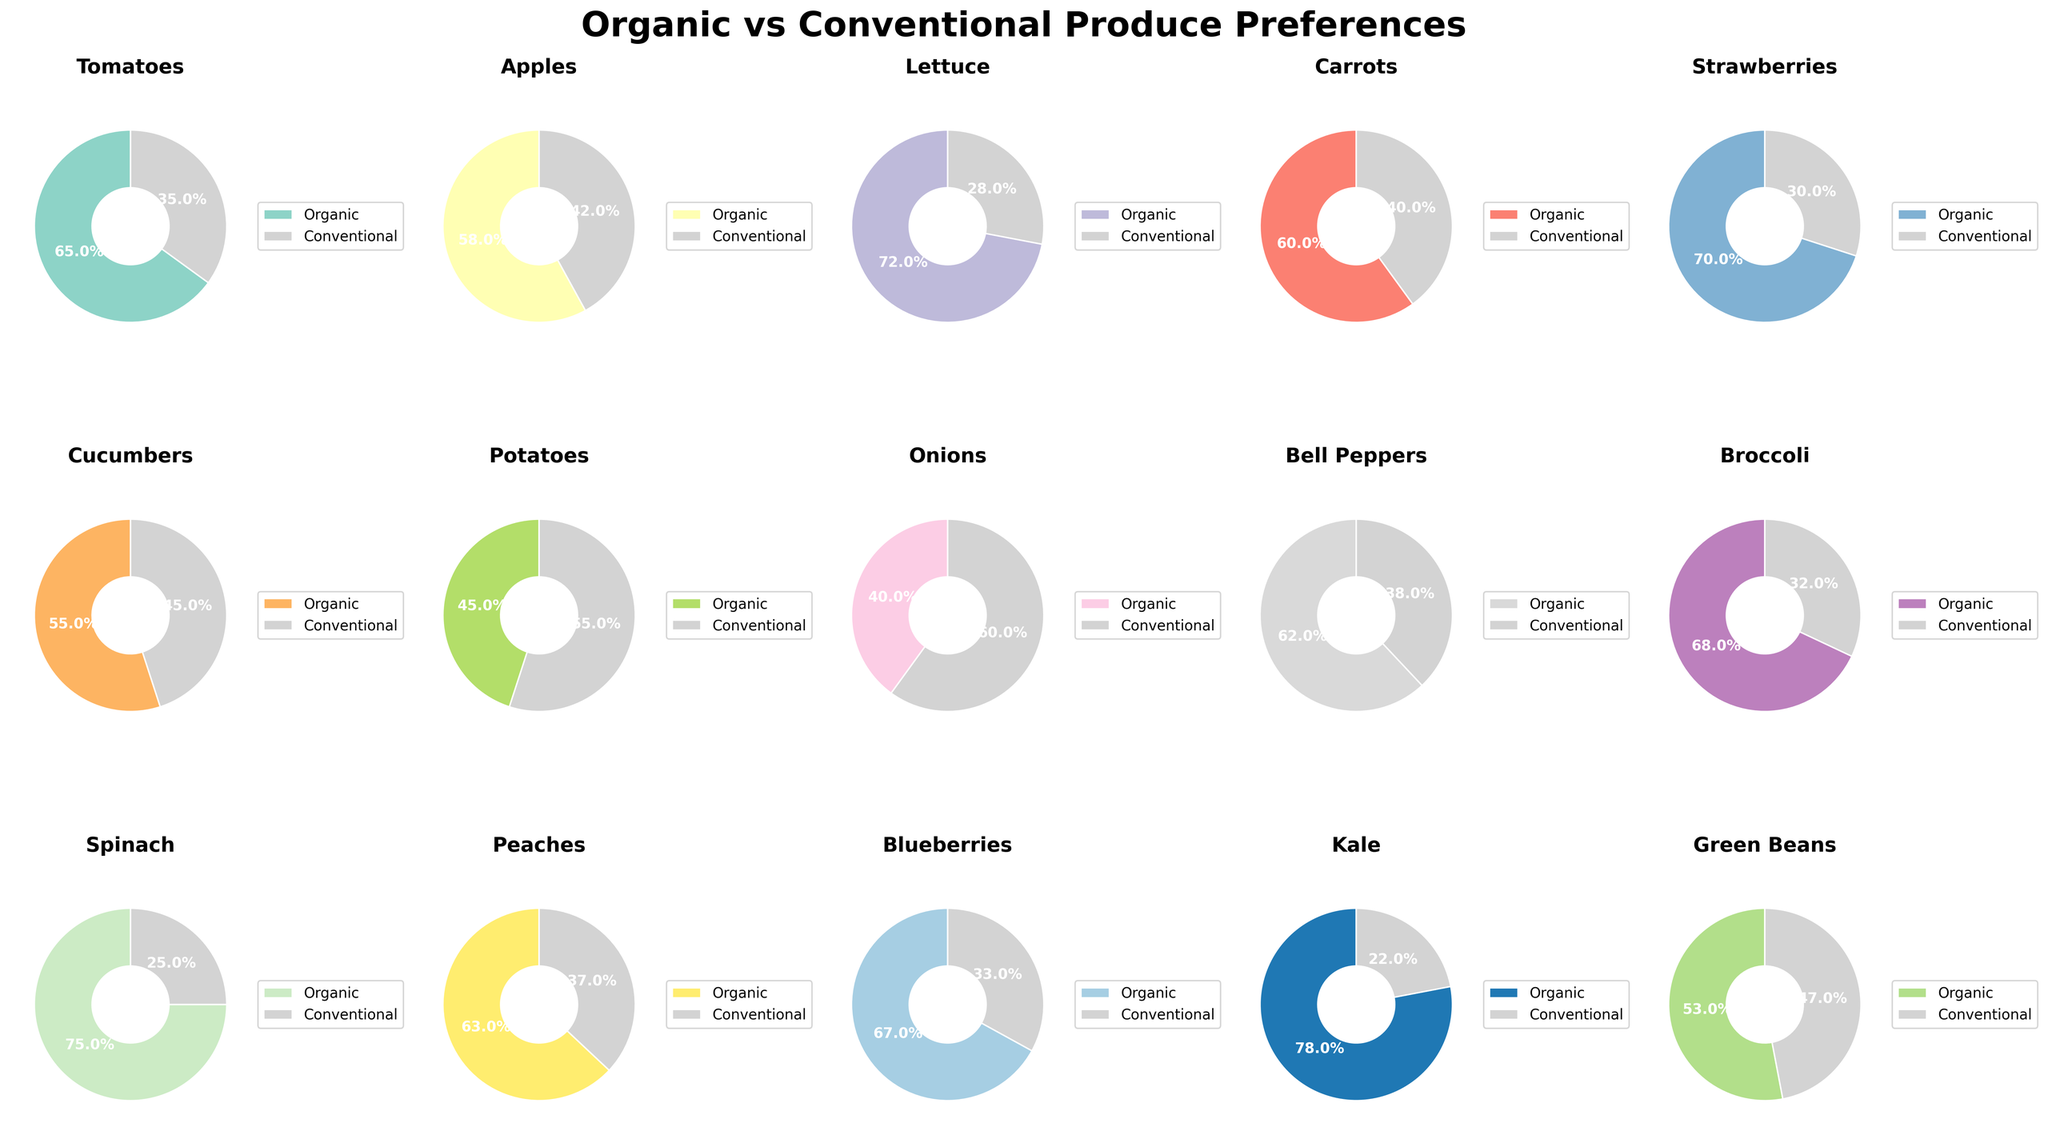Which produce item has the highest preference for organic among customers? To find the produce item with the highest preference for organic, look for the pie chart slice with the highest percentage for organic. In this case, Kale has the highest preference at 78% for organic.
Answer: Kale Which produce item shows the closest preference between organic and conventional? To determine the closest preference, find the produce item where the percentages for organic and conventional are most similar. Cucumbers show 55% preference for organic and 45% for conventional—this 10% difference is the smallest.
Answer: Cucumbers How does the preference for organic tomatoes compare to organic onions in percentage terms? Look at both the pie charts for tomatoes and onions, and compare the percentage of organic preference. Tomatoes have 65% organic preference, while onions have 40%. The difference in preference is 65% - 40% = 25%.
Answer: 25% Which three produce items have over 70% organic preference? Identify and list the produce items where the organic preference slice in the pie chart is greater than 70%. The items are Lettuce (72%), Spinach (75%), Kale (78%).
Answer: Lettuce, Spinach, Kale What is the average preference for organic produce among Tomatoes, Carrots, and Bell Peppers? Calculate the average by summing the organic preference percentages of these three items and dividing by three. Tomatoes (65%), Carrots (60%), and Bell Peppers (62%) sum to 65 + 60 + 62 = 187. The average is 187 / 3 = 62.33%.
Answer: 62.33% Which produce item has the smallest organic percentage, and what is that percentage? Find the pie chart where the organic preference slice is the smallest. Onions have the smallest organic preference at 40%.
Answer: Onions, 40% Compare the preference for organic vs conventional in Strawberries and Blueberries. Which one has a higher organic preference, and by how much? Look at the pie charts for Strawberries and Blueberries. Strawberries have 70% organic preference, while Blueberries have 67%. The difference is 70% - 67% = 3%.
Answer: Strawberries, by 3% 